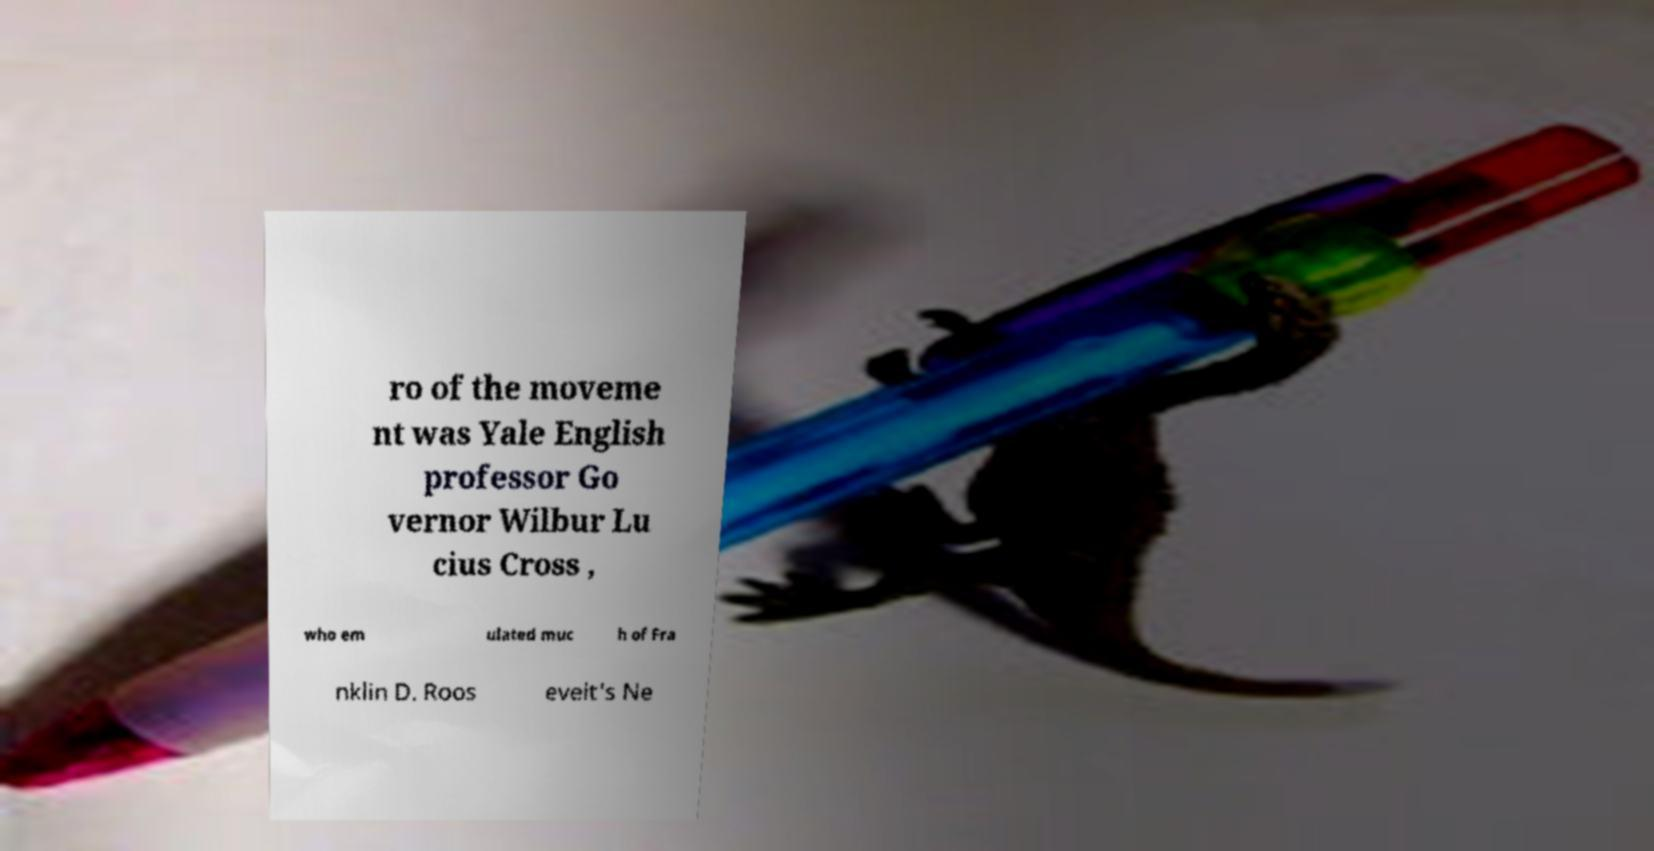Can you accurately transcribe the text from the provided image for me? ro of the moveme nt was Yale English professor Go vernor Wilbur Lu cius Cross , who em ulated muc h of Fra nklin D. Roos evelt's Ne 